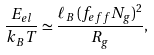<formula> <loc_0><loc_0><loc_500><loc_500>\frac { E _ { e l } } { k _ { B } T } \simeq \frac { \ell _ { B } \, ( f _ { e f f } N _ { g } ) ^ { 2 } } { R _ { g } } ,</formula> 